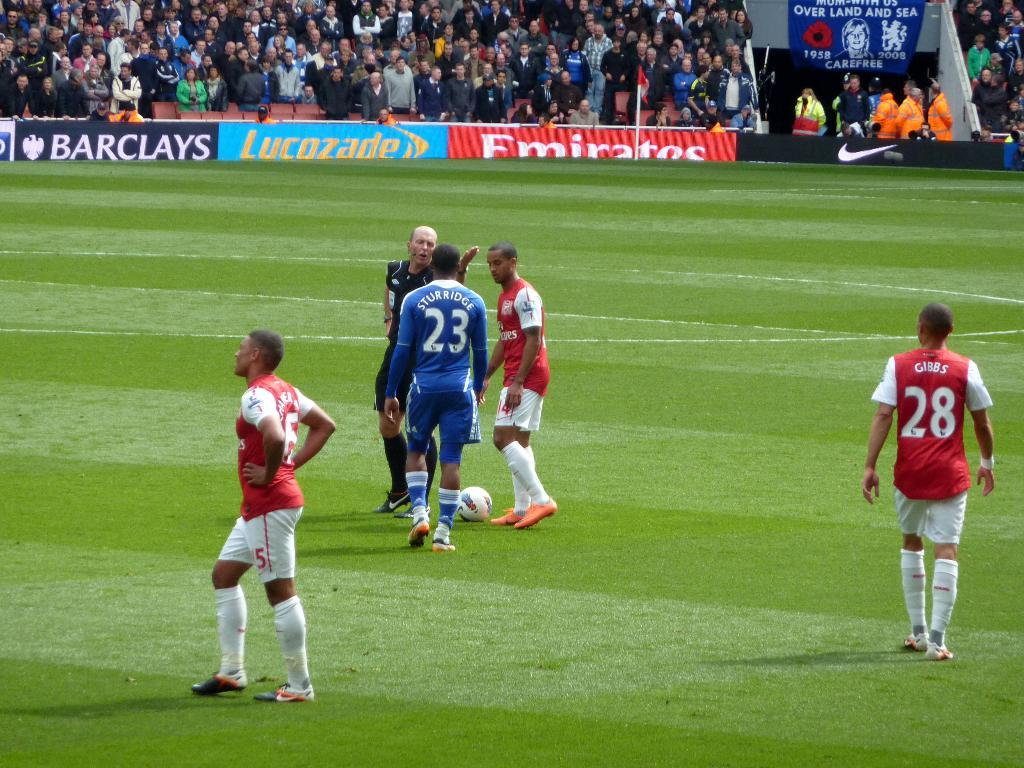<image>
Render a clear and concise summary of the photo. one of the sponsors of the game is Emirates 